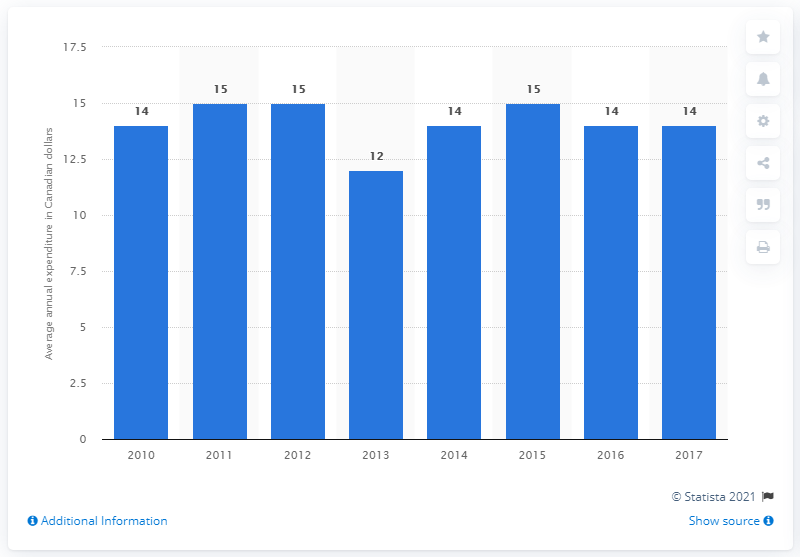What trend can be observed in the expenditure on microwave ovens over the period shown? The image shows a relatively stable trend in the expenditure on microwave ovens, with most years hovering around 14 or 15 Canadian dollars, except for a noticeable dip to 12 dollars in 2013. What could be the reason for the dip in 2013? The dip in 2013 might reflect economic factors such as a temporary market saturation, competitive pricing strategies, or shifts in consumer purchasing preferences during that year. 